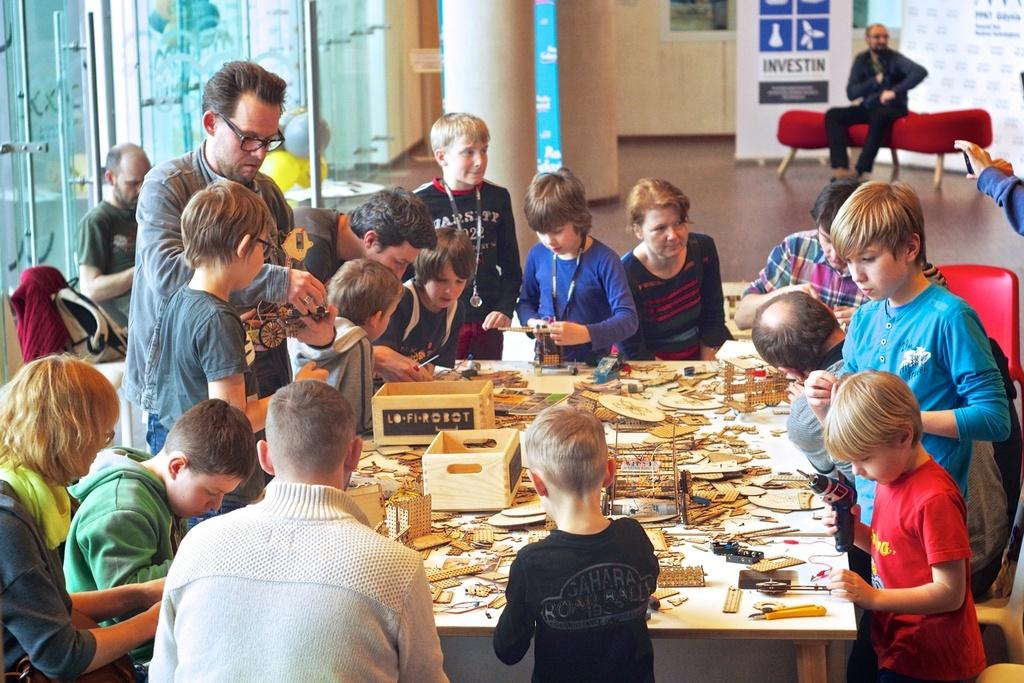How many individuals are present in the image? There are many people in the image. What can be seen in front of the people? There are cardboard pieces in front of the people. Can you describe the seating arrangement of a person in the image? There is a man sitting on a red-colored sofa at the back of the image. What type of flight is taking place in the image? There is no flight present in the image; it features a group of people with cardboard pieces and a man sitting on a red-colored sofa. 